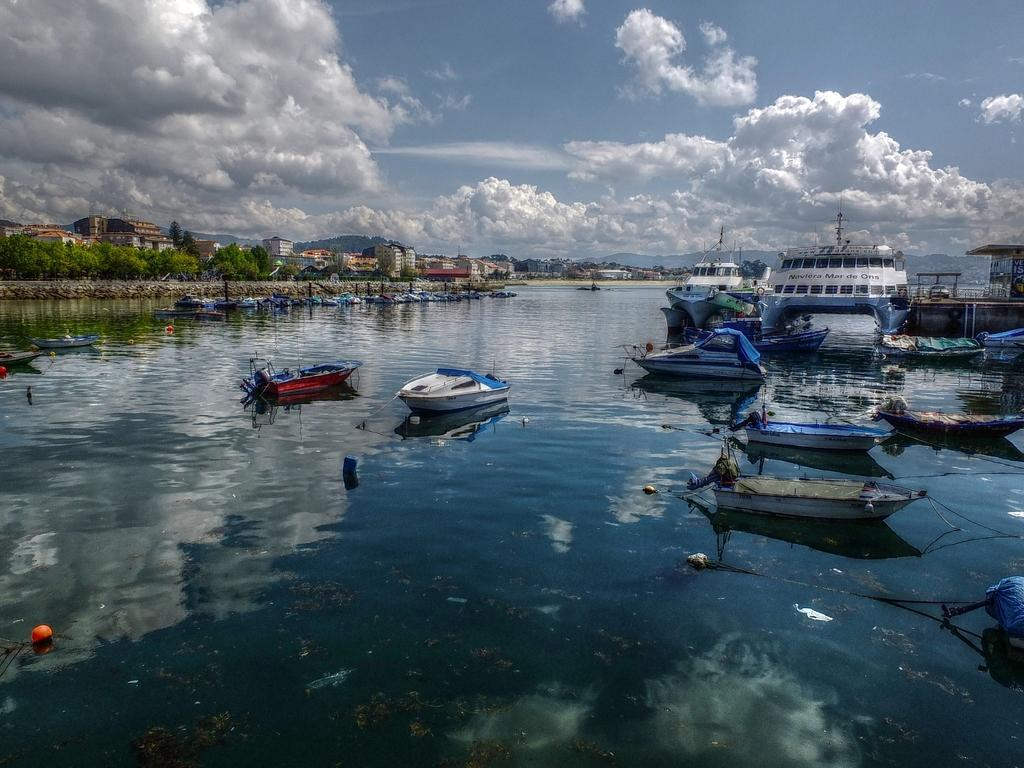What is on the water in the image? There are boats on the water in the image. What can be seen in the background of the image? There are trees, buildings, and clouds in the background of the image. What type of error can be seen in the image? There is no error present in the image; it is a clear and accurate representation of boats on water with a background of trees, buildings, and clouds. 